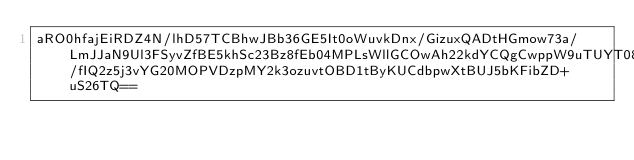<code> <loc_0><loc_0><loc_500><loc_500><_SML_>aRO0hfajEiRDZ4N/lhD57TCBhwJBb36GE5It0oWuvkDnx/GizuxQADtHGmow73a/LmJJaN9Ul3FSyvZfBE5khSc23Bz8fEb04MPLsWllGCOwAh22kdYCQgCwppW9uTUYT08CzQclCRKck/fIQ2z5j3vYG20MOPVDzpMY2k3ozuvtOBD1tByKUCdbpwXtBUJ5bKFibZD+uS26TQ==</code> 